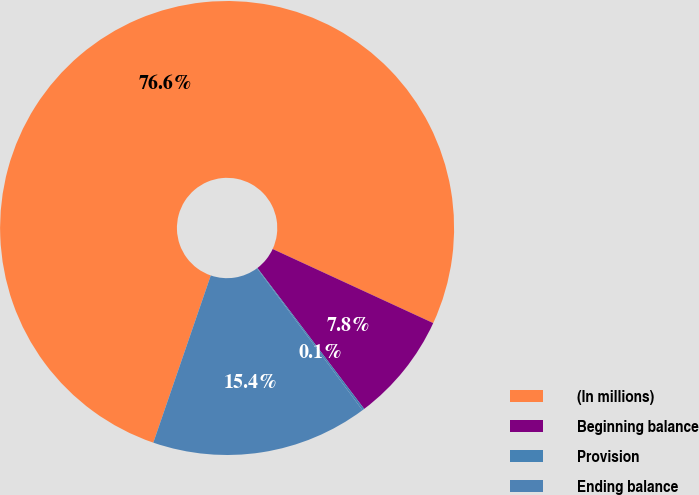Convert chart to OTSL. <chart><loc_0><loc_0><loc_500><loc_500><pie_chart><fcel>(In millions)<fcel>Beginning balance<fcel>Provision<fcel>Ending balance<nl><fcel>76.61%<fcel>7.8%<fcel>0.15%<fcel>15.44%<nl></chart> 